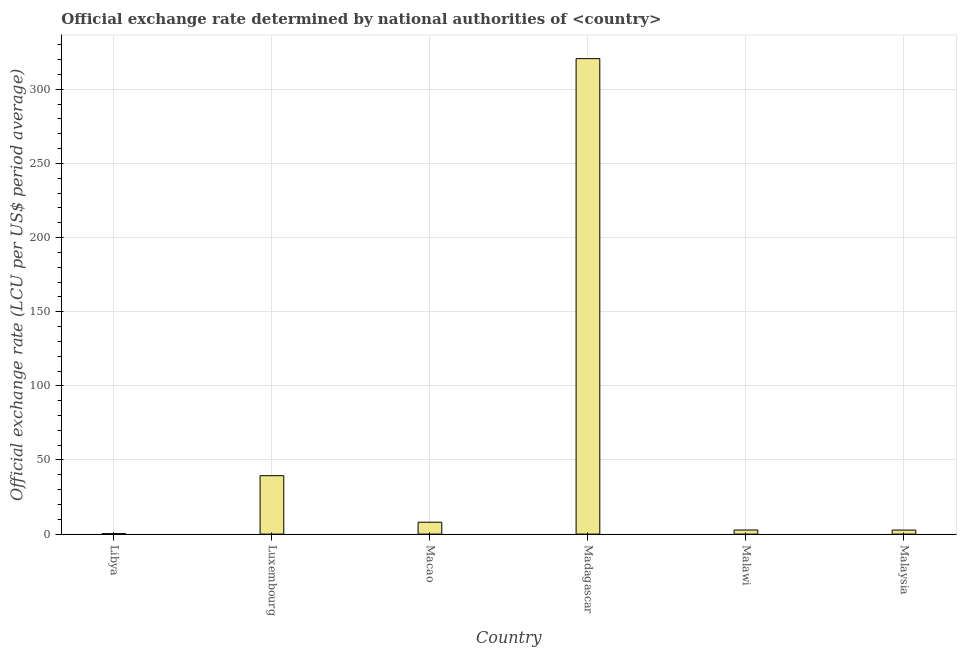Does the graph contain grids?
Give a very brief answer. Yes. What is the title of the graph?
Provide a short and direct response. Official exchange rate determined by national authorities of <country>. What is the label or title of the Y-axis?
Provide a succinct answer. Official exchange rate (LCU per US$ period average). What is the official exchange rate in Madagascar?
Make the answer very short. 320.69. Across all countries, what is the maximum official exchange rate?
Give a very brief answer. 320.69. Across all countries, what is the minimum official exchange rate?
Your answer should be very brief. 0.3. In which country was the official exchange rate maximum?
Your answer should be very brief. Madagascar. In which country was the official exchange rate minimum?
Your answer should be compact. Libya. What is the sum of the official exchange rate?
Your response must be concise. 373.89. What is the difference between the official exchange rate in Madagascar and Malawi?
Provide a succinct answer. 317.93. What is the average official exchange rate per country?
Give a very brief answer. 62.32. What is the median official exchange rate?
Provide a succinct answer. 5.4. What is the ratio of the official exchange rate in Macao to that in Malawi?
Your response must be concise. 2.91. Is the official exchange rate in Libya less than that in Madagascar?
Keep it short and to the point. Yes. Is the difference between the official exchange rate in Macao and Malawi greater than the difference between any two countries?
Your answer should be compact. No. What is the difference between the highest and the second highest official exchange rate?
Your response must be concise. 281.28. What is the difference between the highest and the lowest official exchange rate?
Ensure brevity in your answer.  320.39. How many countries are there in the graph?
Offer a very short reply. 6. Are the values on the major ticks of Y-axis written in scientific E-notation?
Keep it short and to the point. No. What is the Official exchange rate (LCU per US$ period average) in Libya?
Your answer should be very brief. 0.3. What is the Official exchange rate (LCU per US$ period average) in Luxembourg?
Offer a terse response. 39.4. What is the Official exchange rate (LCU per US$ period average) of Macao?
Offer a terse response. 8.03. What is the Official exchange rate (LCU per US$ period average) of Madagascar?
Give a very brief answer. 320.69. What is the Official exchange rate (LCU per US$ period average) of Malawi?
Your response must be concise. 2.76. What is the Official exchange rate (LCU per US$ period average) of Malaysia?
Keep it short and to the point. 2.71. What is the difference between the Official exchange rate (LCU per US$ period average) in Libya and Luxembourg?
Your response must be concise. -39.1. What is the difference between the Official exchange rate (LCU per US$ period average) in Libya and Macao?
Make the answer very short. -7.73. What is the difference between the Official exchange rate (LCU per US$ period average) in Libya and Madagascar?
Your answer should be very brief. -320.39. What is the difference between the Official exchange rate (LCU per US$ period average) in Libya and Malawi?
Make the answer very short. -2.46. What is the difference between the Official exchange rate (LCU per US$ period average) in Libya and Malaysia?
Your answer should be very brief. -2.41. What is the difference between the Official exchange rate (LCU per US$ period average) in Luxembourg and Macao?
Offer a very short reply. 31.37. What is the difference between the Official exchange rate (LCU per US$ period average) in Luxembourg and Madagascar?
Make the answer very short. -281.28. What is the difference between the Official exchange rate (LCU per US$ period average) in Luxembourg and Malawi?
Give a very brief answer. 36.64. What is the difference between the Official exchange rate (LCU per US$ period average) in Luxembourg and Malaysia?
Your answer should be very brief. 36.7. What is the difference between the Official exchange rate (LCU per US$ period average) in Macao and Madagascar?
Ensure brevity in your answer.  -312.65. What is the difference between the Official exchange rate (LCU per US$ period average) in Macao and Malawi?
Give a very brief answer. 5.27. What is the difference between the Official exchange rate (LCU per US$ period average) in Macao and Malaysia?
Make the answer very short. 5.33. What is the difference between the Official exchange rate (LCU per US$ period average) in Madagascar and Malawi?
Your answer should be compact. 317.93. What is the difference between the Official exchange rate (LCU per US$ period average) in Madagascar and Malaysia?
Provide a succinct answer. 317.98. What is the difference between the Official exchange rate (LCU per US$ period average) in Malawi and Malaysia?
Keep it short and to the point. 0.05. What is the ratio of the Official exchange rate (LCU per US$ period average) in Libya to that in Luxembourg?
Keep it short and to the point. 0.01. What is the ratio of the Official exchange rate (LCU per US$ period average) in Libya to that in Macao?
Ensure brevity in your answer.  0.04. What is the ratio of the Official exchange rate (LCU per US$ period average) in Libya to that in Madagascar?
Offer a very short reply. 0. What is the ratio of the Official exchange rate (LCU per US$ period average) in Libya to that in Malawi?
Your answer should be very brief. 0.11. What is the ratio of the Official exchange rate (LCU per US$ period average) in Libya to that in Malaysia?
Give a very brief answer. 0.11. What is the ratio of the Official exchange rate (LCU per US$ period average) in Luxembourg to that in Macao?
Make the answer very short. 4.91. What is the ratio of the Official exchange rate (LCU per US$ period average) in Luxembourg to that in Madagascar?
Offer a terse response. 0.12. What is the ratio of the Official exchange rate (LCU per US$ period average) in Luxembourg to that in Malawi?
Your response must be concise. 14.28. What is the ratio of the Official exchange rate (LCU per US$ period average) in Luxembourg to that in Malaysia?
Give a very brief answer. 14.55. What is the ratio of the Official exchange rate (LCU per US$ period average) in Macao to that in Madagascar?
Offer a terse response. 0.03. What is the ratio of the Official exchange rate (LCU per US$ period average) in Macao to that in Malawi?
Ensure brevity in your answer.  2.91. What is the ratio of the Official exchange rate (LCU per US$ period average) in Macao to that in Malaysia?
Offer a terse response. 2.97. What is the ratio of the Official exchange rate (LCU per US$ period average) in Madagascar to that in Malawi?
Your response must be concise. 116.21. What is the ratio of the Official exchange rate (LCU per US$ period average) in Madagascar to that in Malaysia?
Your response must be concise. 118.39. 